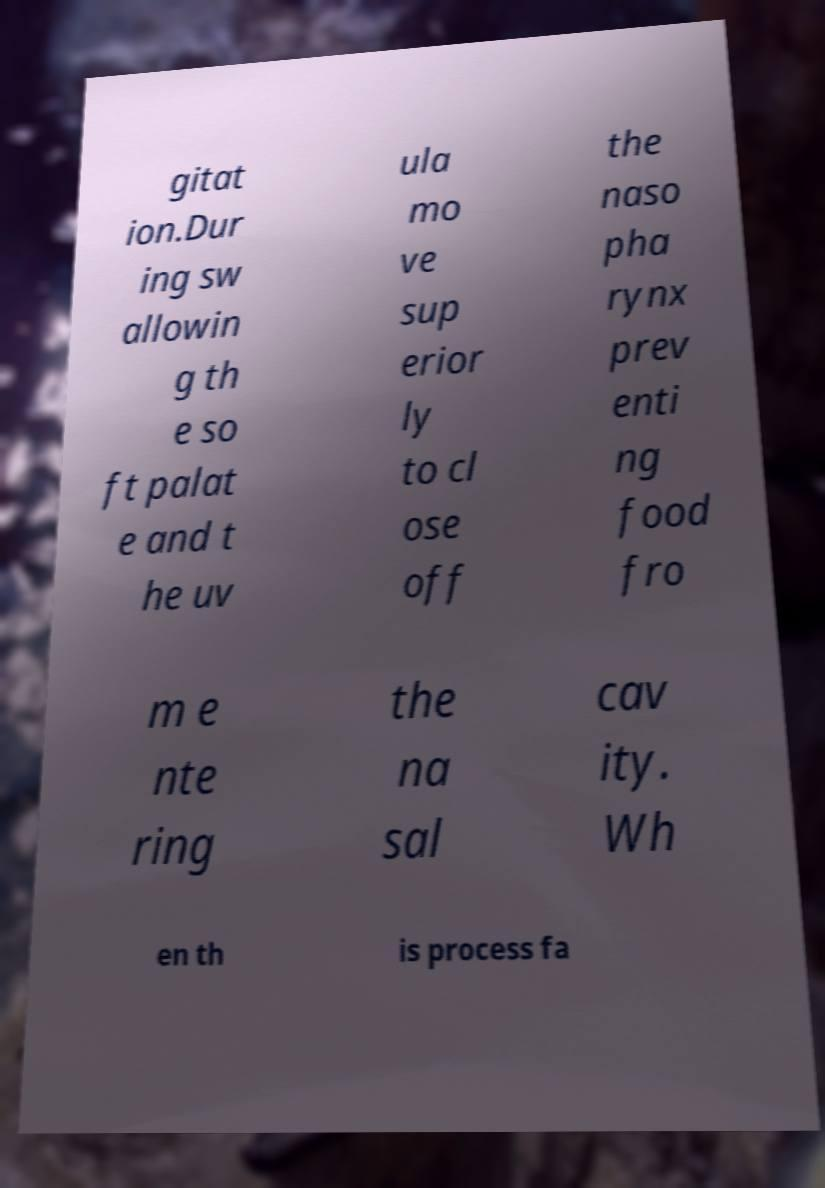What messages or text are displayed in this image? I need them in a readable, typed format. gitat ion.Dur ing sw allowin g th e so ft palat e and t he uv ula mo ve sup erior ly to cl ose off the naso pha rynx prev enti ng food fro m e nte ring the na sal cav ity. Wh en th is process fa 